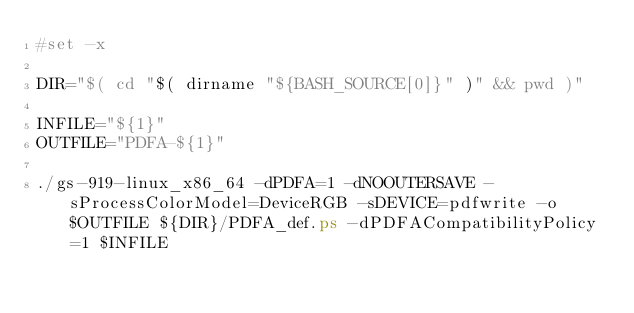Convert code to text. <code><loc_0><loc_0><loc_500><loc_500><_Bash_>#set -x

DIR="$( cd "$( dirname "${BASH_SOURCE[0]}" )" && pwd )"

INFILE="${1}"
OUTFILE="PDFA-${1}"

./gs-919-linux_x86_64 -dPDFA=1 -dNOOUTERSAVE -sProcessColorModel=DeviceRGB -sDEVICE=pdfwrite -o $OUTFILE ${DIR}/PDFA_def.ps -dPDFACompatibilityPolicy=1 $INFILE
</code> 